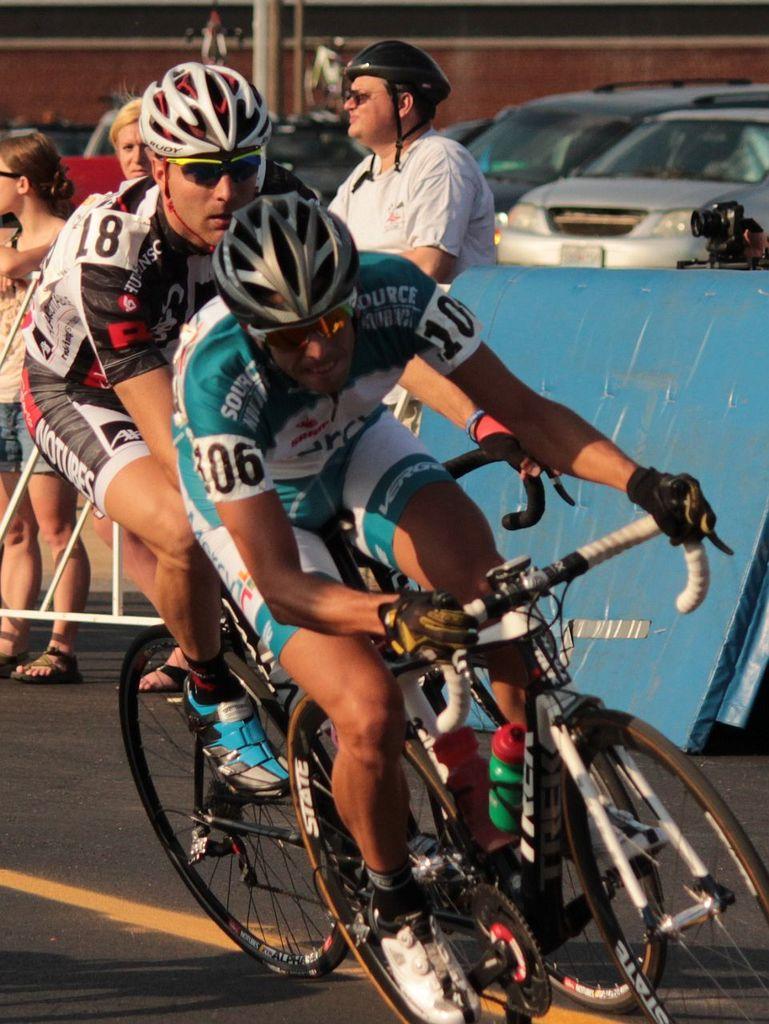Please provide a concise description of this image. This image is taken in outdoors. There are five persons in this image. At the bottom of the image there is a road. In the left side of the image a woman standing on the road and a railing is present. In the middle of the image two men on bicycle riding on road and the man with helmet is standing at the back. In the right side of the image there is a camera and a cars were there. 